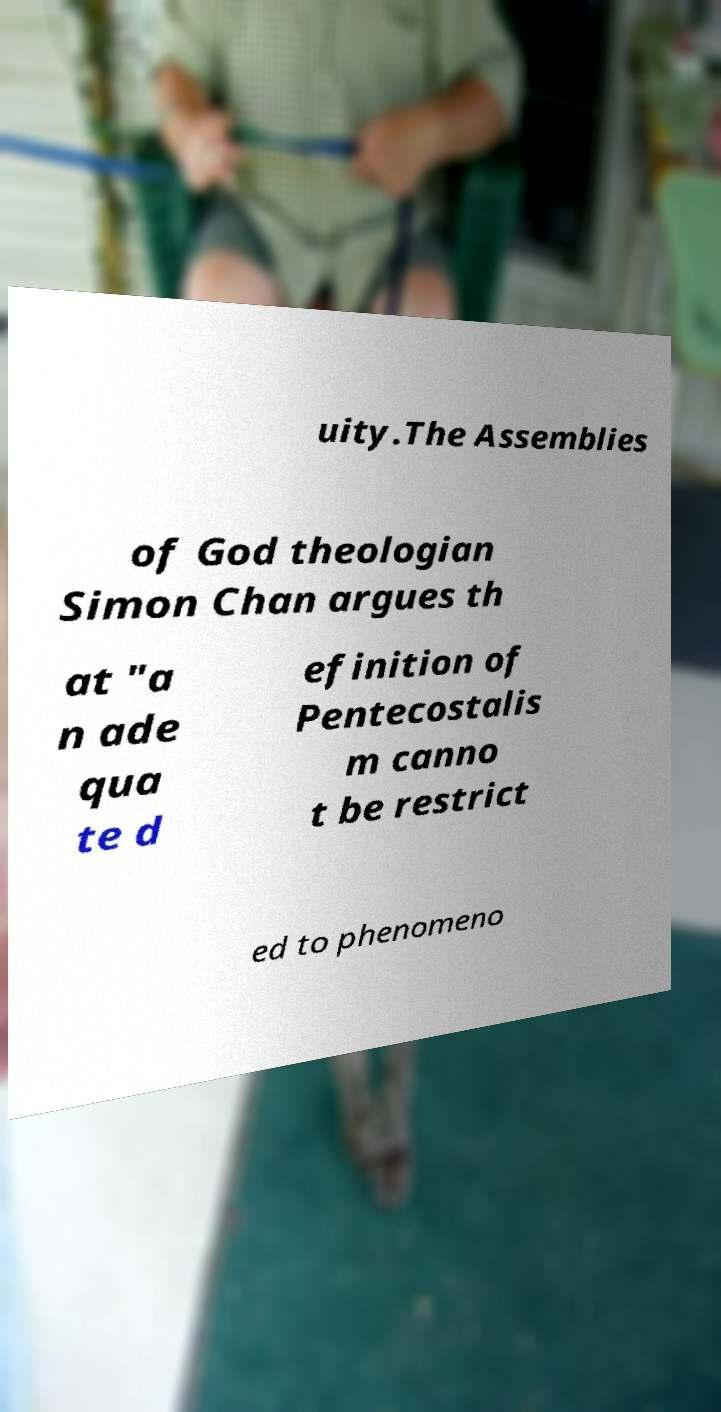Could you assist in decoding the text presented in this image and type it out clearly? uity.The Assemblies of God theologian Simon Chan argues th at "a n ade qua te d efinition of Pentecostalis m canno t be restrict ed to phenomeno 